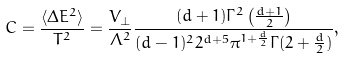Convert formula to latex. <formula><loc_0><loc_0><loc_500><loc_500>C = \frac { \langle \Delta E ^ { 2 } \rangle } { T ^ { 2 } } = \frac { V _ { \bot } } { \Lambda ^ { 2 } } \frac { ( d + 1 ) \Gamma ^ { 2 } \left ( \frac { d + 1 } { 2 } \right ) } { ( d - 1 ) ^ { 2 } 2 ^ { d + 5 } \pi ^ { 1 + \frac { d } { 2 } } \Gamma ( 2 + \frac { d } { 2 } ) } ,</formula> 